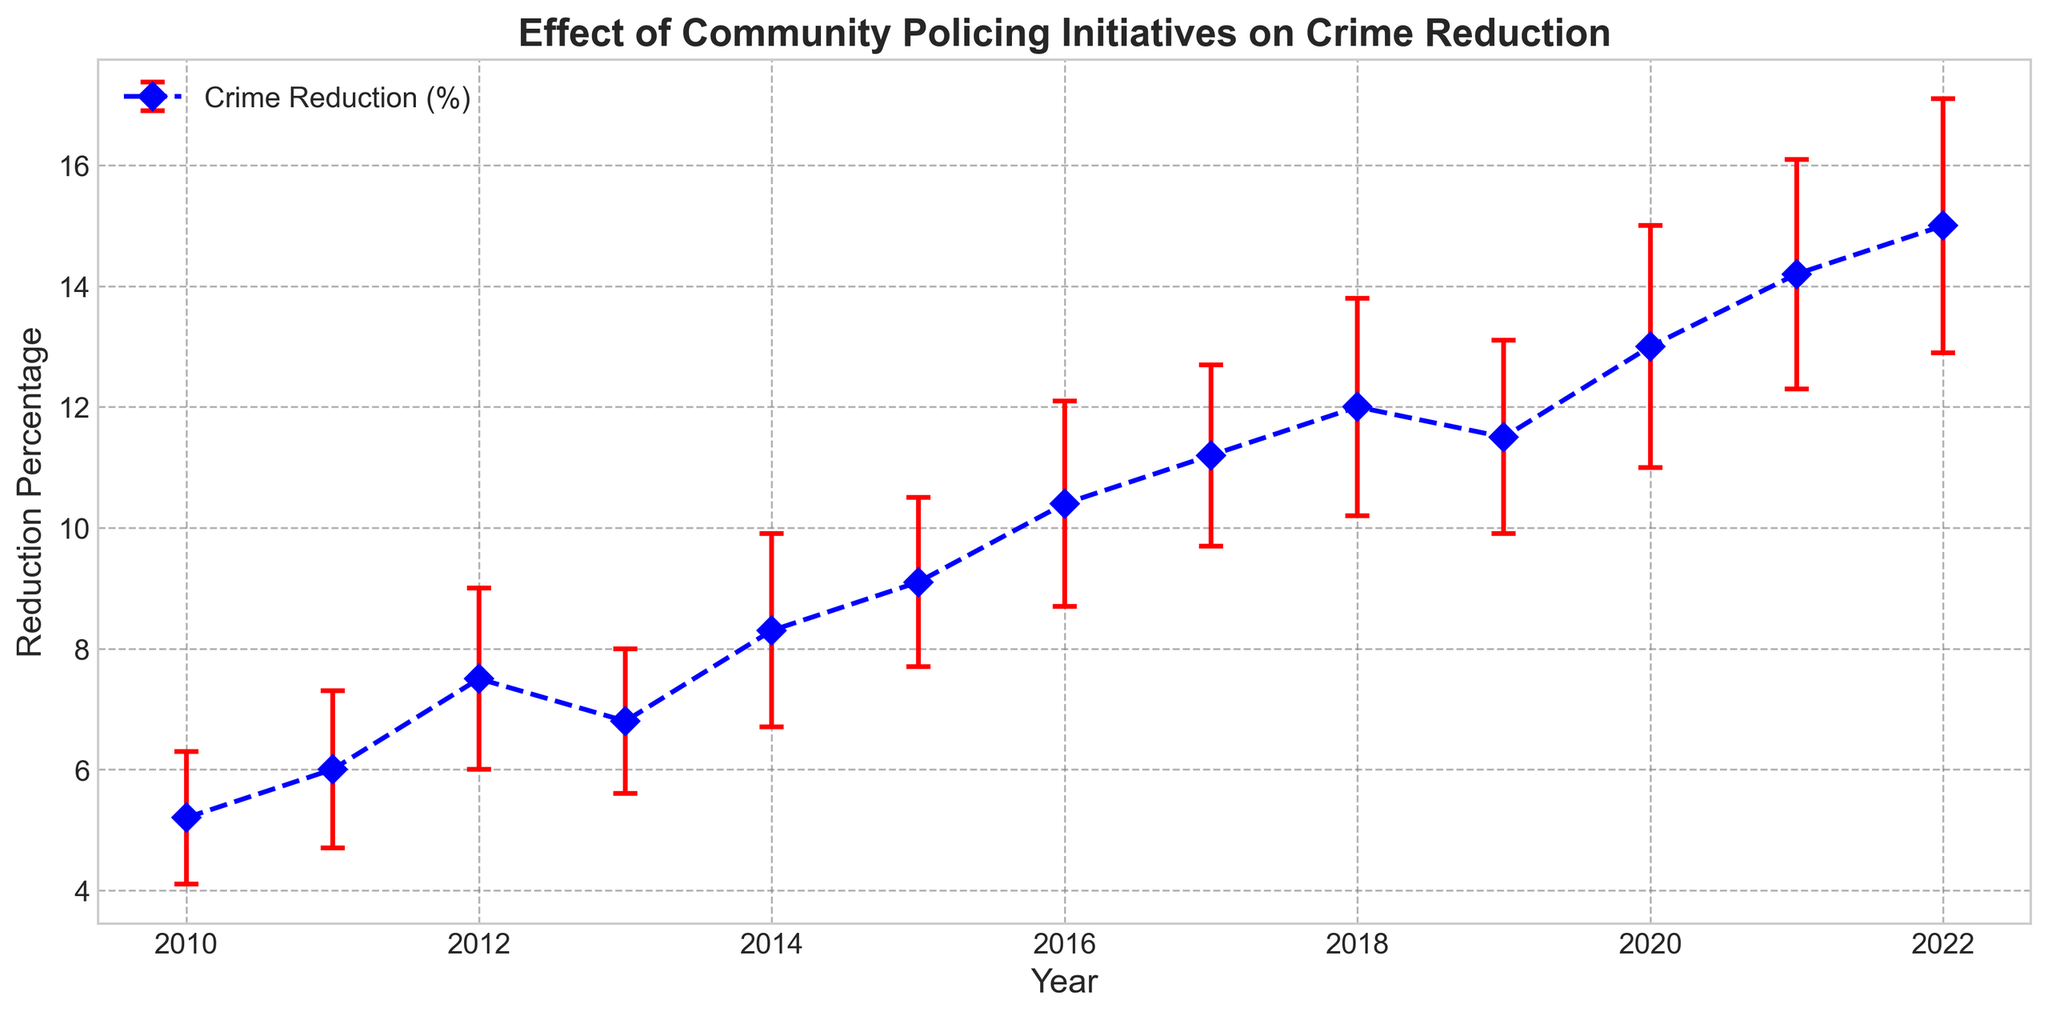Which year saw the highest reduction percentage in crime? To identify the year with the highest reduction percentage, find the year where the data point is highest. The highest data point is in 2022.
Answer: 2022 How many years showed a reduction percentage greater than 10%? Count the data points where the reduction percentage is over 10%. These years are 2016 to 2022, giving us seven years.
Answer: 7 What is the average reduction percentage from 2010 to 2015? Sum the reduction percentages from 2010 to 2015: 5.2 + 6.0 + 7.5 + 6.8 + 8.3 + 9.1 = 42.9. Divide by the number of years (6). The average is 42.9/6.
Answer: 7.15 What's the difference in the reduction percentage between 2022 and 2010? Subtract the reduction percentage of 2010 from 2022: 15.0 - 5.2 = 9.8.
Answer: 9.8 Which year had the smallest error range? Identify the year with the smallest error bar. The year 2010 has the smallest error range of 1.1.
Answer: 2010 How much did the reduction percentage increase between 2014 and 2019? Subtract the reduction percentage of 2014 from 2019: 11.5 - 8.3 = 3.2.
Answer: 3.2 Visually, how does the error range in 2020 compare to that in 2011? Compare the error lengths of the two years. The error range in 2020 is visibly larger than that in 2011.
Answer: Larger What's the trend of the reduction percentages over the years? Observe the overall movement of the reduction percentages. The trend is an increasing one from 2010 to 2022.
Answer: Increasing What is the approximate error range for the year 2017? Look at the length of the error bar for 2017. The error range is 1.5.
Answer: 1.5 Comparing 2015 and 2021, which year had a higher reduction percentage and by how much? Find the reduction percentages for both years and subtract them: 14.2 (2021) - 9.1 (2015) = 5.1.
Answer: 2021 by 5.1 